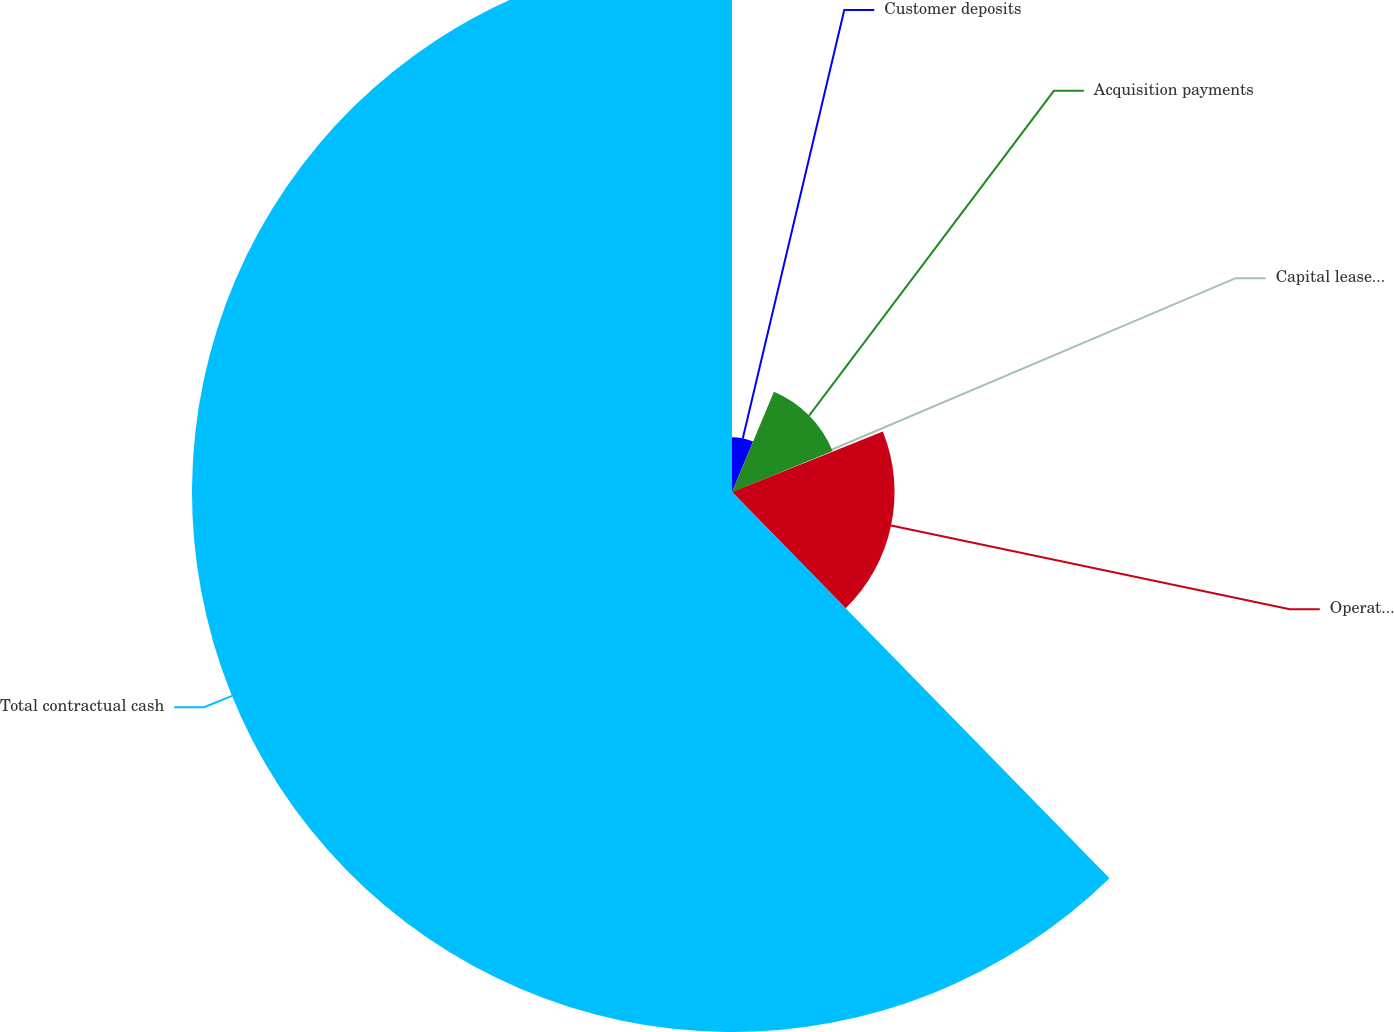Convert chart to OTSL. <chart><loc_0><loc_0><loc_500><loc_500><pie_chart><fcel>Customer deposits<fcel>Acquisition payments<fcel>Capital lease obligations<fcel>Operating leases<fcel>Total contractual cash<nl><fcel>6.31%<fcel>12.53%<fcel>0.08%<fcel>18.76%<fcel>62.32%<nl></chart> 